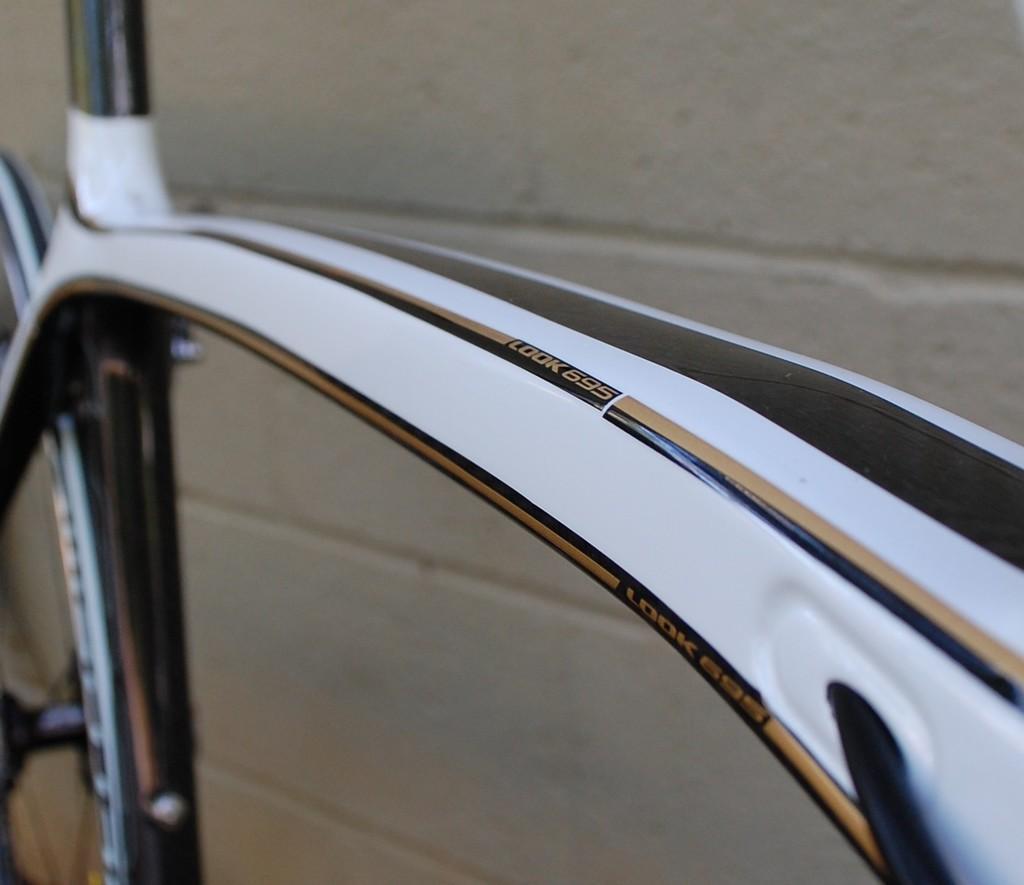How would you summarize this image in a sentence or two? In this image we can see the bicycle near the wall. 